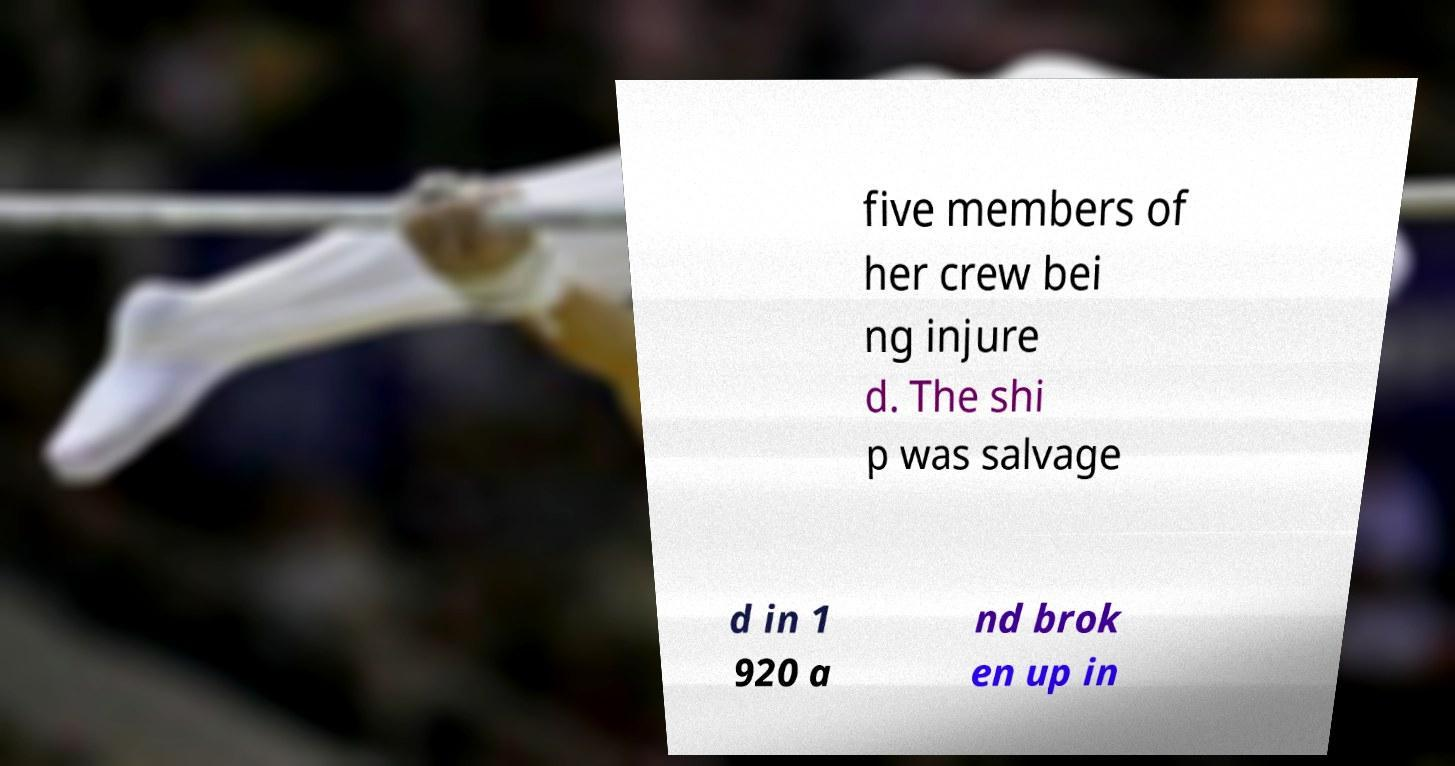Can you accurately transcribe the text from the provided image for me? five members of her crew bei ng injure d. The shi p was salvage d in 1 920 a nd brok en up in 